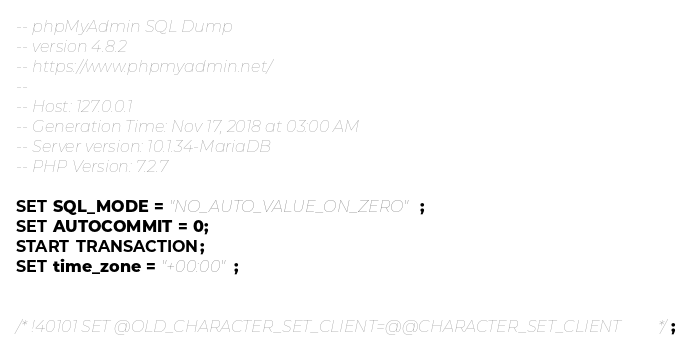Convert code to text. <code><loc_0><loc_0><loc_500><loc_500><_SQL_>-- phpMyAdmin SQL Dump
-- version 4.8.2
-- https://www.phpmyadmin.net/
--
-- Host: 127.0.0.1
-- Generation Time: Nov 17, 2018 at 03:00 AM
-- Server version: 10.1.34-MariaDB
-- PHP Version: 7.2.7

SET SQL_MODE = "NO_AUTO_VALUE_ON_ZERO";
SET AUTOCOMMIT = 0;
START TRANSACTION;
SET time_zone = "+00:00";


/*!40101 SET @OLD_CHARACTER_SET_CLIENT=@@CHARACTER_SET_CLIENT */;</code> 